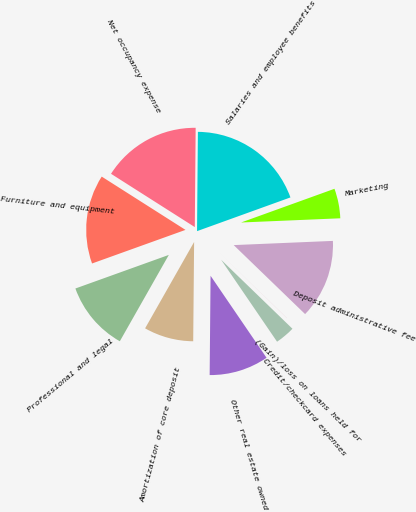Convert chart. <chart><loc_0><loc_0><loc_500><loc_500><pie_chart><fcel>Salaries and employee benefits<fcel>Net occupancy expense<fcel>Furniture and equipment<fcel>Professional and legal<fcel>Amortization of core deposit<fcel>Other real estate owned<fcel>Credit/checkcard expenses<fcel>(Gain)/loss on loans held for<fcel>Deposit administrative fee<fcel>Marketing<nl><fcel>19.35%<fcel>16.12%<fcel>14.51%<fcel>11.29%<fcel>8.07%<fcel>9.68%<fcel>3.23%<fcel>0.01%<fcel>12.9%<fcel>4.84%<nl></chart> 